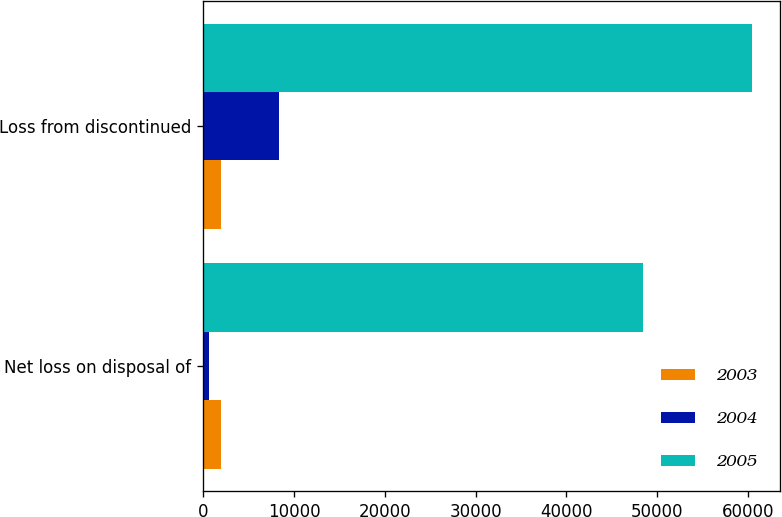Convert chart. <chart><loc_0><loc_0><loc_500><loc_500><stacked_bar_chart><ecel><fcel>Net loss on disposal of<fcel>Loss from discontinued<nl><fcel>2003<fcel>1935<fcel>1935<nl><fcel>2004<fcel>625<fcel>8345<nl><fcel>2005<fcel>48458<fcel>60475<nl></chart> 